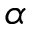Convert formula to latex. <formula><loc_0><loc_0><loc_500><loc_500>\alpha</formula> 